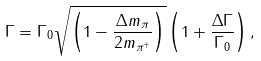Convert formula to latex. <formula><loc_0><loc_0><loc_500><loc_500>\Gamma = \Gamma _ { 0 } \sqrt { \left ( 1 - \frac { \Delta m _ { \pi } } { 2 m _ { \pi ^ { + } } } \right ) } \left ( 1 + \frac { \Delta \Gamma } { \Gamma _ { 0 } } \right ) ,</formula> 